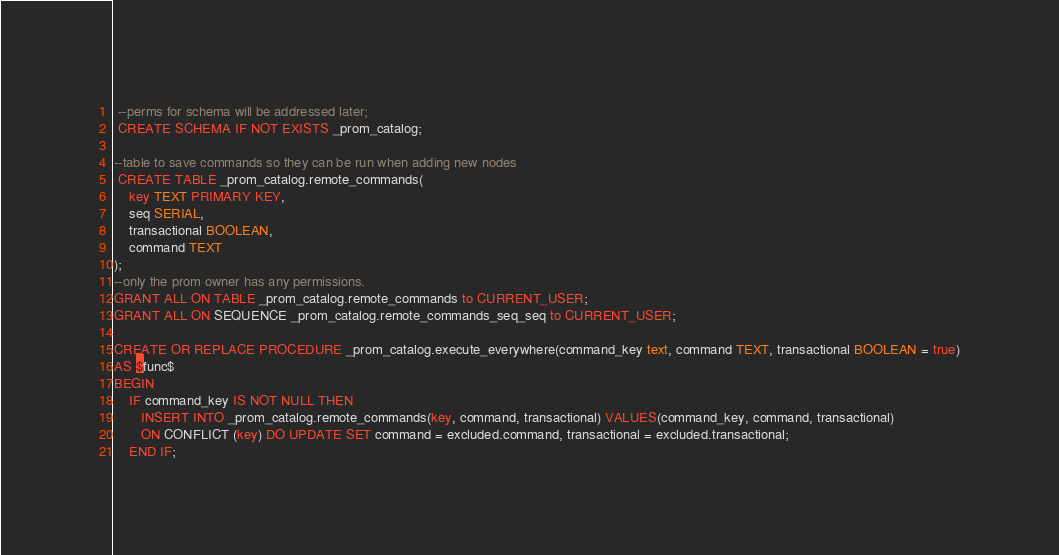<code> <loc_0><loc_0><loc_500><loc_500><_SQL_> --perms for schema will be addressed later;
 CREATE SCHEMA IF NOT EXISTS _prom_catalog;

--table to save commands so they can be run when adding new nodes
 CREATE TABLE _prom_catalog.remote_commands(
    key TEXT PRIMARY KEY,
    seq SERIAL,
    transactional BOOLEAN,
    command TEXT
);
--only the prom owner has any permissions.
GRANT ALL ON TABLE _prom_catalog.remote_commands to CURRENT_USER;
GRANT ALL ON SEQUENCE _prom_catalog.remote_commands_seq_seq to CURRENT_USER;

CREATE OR REPLACE PROCEDURE _prom_catalog.execute_everywhere(command_key text, command TEXT, transactional BOOLEAN = true)
AS $func$
BEGIN
    IF command_key IS NOT NULL THEN
       INSERT INTO _prom_catalog.remote_commands(key, command, transactional) VALUES(command_key, command, transactional)
       ON CONFLICT (key) DO UPDATE SET command = excluded.command, transactional = excluded.transactional;
    END IF;
</code> 